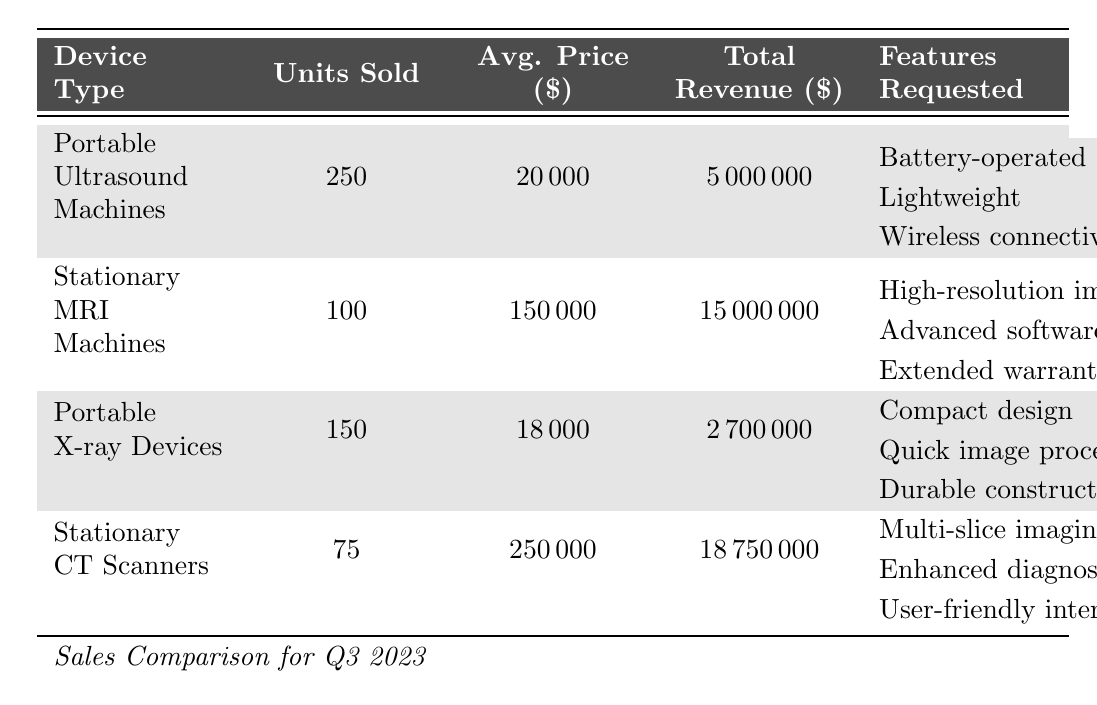What is the total revenue generated by Portable Ultrasound Machines? According to the table, the total revenue for Portable Ultrasound Machines is listed as \$5,000,000.
Answer: \$5,000,000 How many units were sold of Stationary CT Scanners? The table indicates that 75 units of Stationary CT Scanners were sold.
Answer: 75 What is the average price of Portable X-ray Devices? From the table, the average price of Portable X-ray Devices is \$18,000.
Answer: \$18,000 Which device type generated the highest total revenue? By examining the total revenue figures, Stationary CT Scanners generated \$18,750,000, which is the highest among all listed devices.
Answer: Stationary CT Scanners What is the total number of units sold for all Portable devices? The total units sold for Portable devices is the sum of Portable Ultrasound Machines (250) and Portable X-ray Devices (150), which equals 400 units.
Answer: 400 How much higher is the average price of Stationary MRI Machines compared to Portable Ultrasound Machines? The average price of Stationary MRI Machines is \$150,000 and that of Portable Ultrasound Machines is \$20,000. The difference is \$150,000 - \$20,000 = \$130,000.
Answer: \$130,000 Are there any features requested for Portable X-ray Devices related to image processing? Yes, the features requested for Portable X-ray Devices include "Quick image processing." This confirms that image processing is a requested feature for this device.
Answer: Yes Which device type sold fewer units: Stationary MRI Machines or Stationary CT Scanners? Stationary MRI Machines sold 100 units and Stationary CT Scanners sold 75 units. Since 75 is less than 100, Stationary CT Scanners sold fewer units.
Answer: Stationary CT Scanners What percentage of the total revenue in Q3 2023 comes from Portable Ultrasound Machines? The total revenue from all devices is \$5,000,000 (Portable Ultrasound) + \$15,000,000 (MRI) + \$2,700,000 (Portable X-ray) + \$18,750,000 (CT) = \$41,450,000. The revenue from Portable Ultrasound Machines is \$5,000,000, so the percentage is (\$5,000,000 / \$41,450,000) × 100 ≈ 12.06%.
Answer: 12.06% What is the overall average price of all four device types combined? The average price is calculated as follows: (20,000 + 150,000 + 18,000 + 250,000) / 4 = 103,000.
Answer: \$103,000 